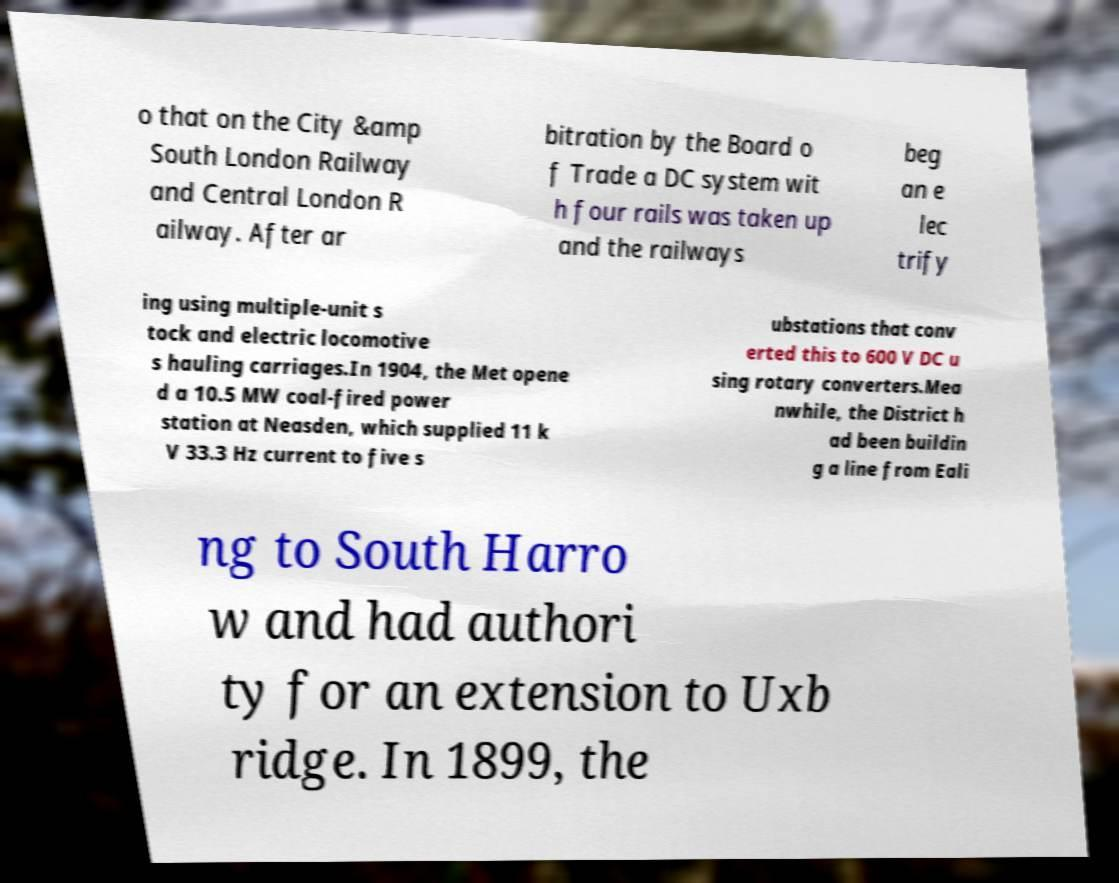Could you assist in decoding the text presented in this image and type it out clearly? o that on the City &amp South London Railway and Central London R ailway. After ar bitration by the Board o f Trade a DC system wit h four rails was taken up and the railways beg an e lec trify ing using multiple-unit s tock and electric locomotive s hauling carriages.In 1904, the Met opene d a 10.5 MW coal-fired power station at Neasden, which supplied 11 k V 33.3 Hz current to five s ubstations that conv erted this to 600 V DC u sing rotary converters.Mea nwhile, the District h ad been buildin g a line from Eali ng to South Harro w and had authori ty for an extension to Uxb ridge. In 1899, the 